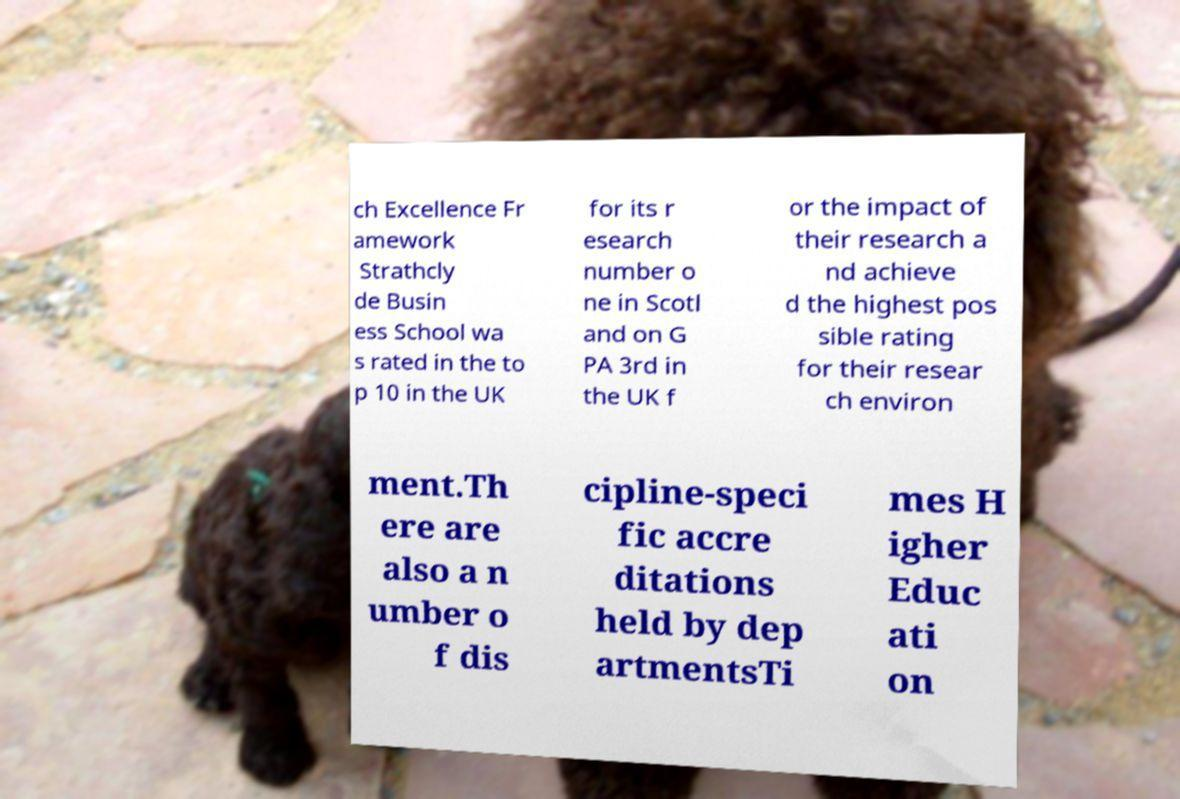There's text embedded in this image that I need extracted. Can you transcribe it verbatim? ch Excellence Fr amework Strathcly de Busin ess School wa s rated in the to p 10 in the UK for its r esearch number o ne in Scotl and on G PA 3rd in the UK f or the impact of their research a nd achieve d the highest pos sible rating for their resear ch environ ment.Th ere are also a n umber o f dis cipline-speci fic accre ditations held by dep artmentsTi mes H igher Educ ati on 